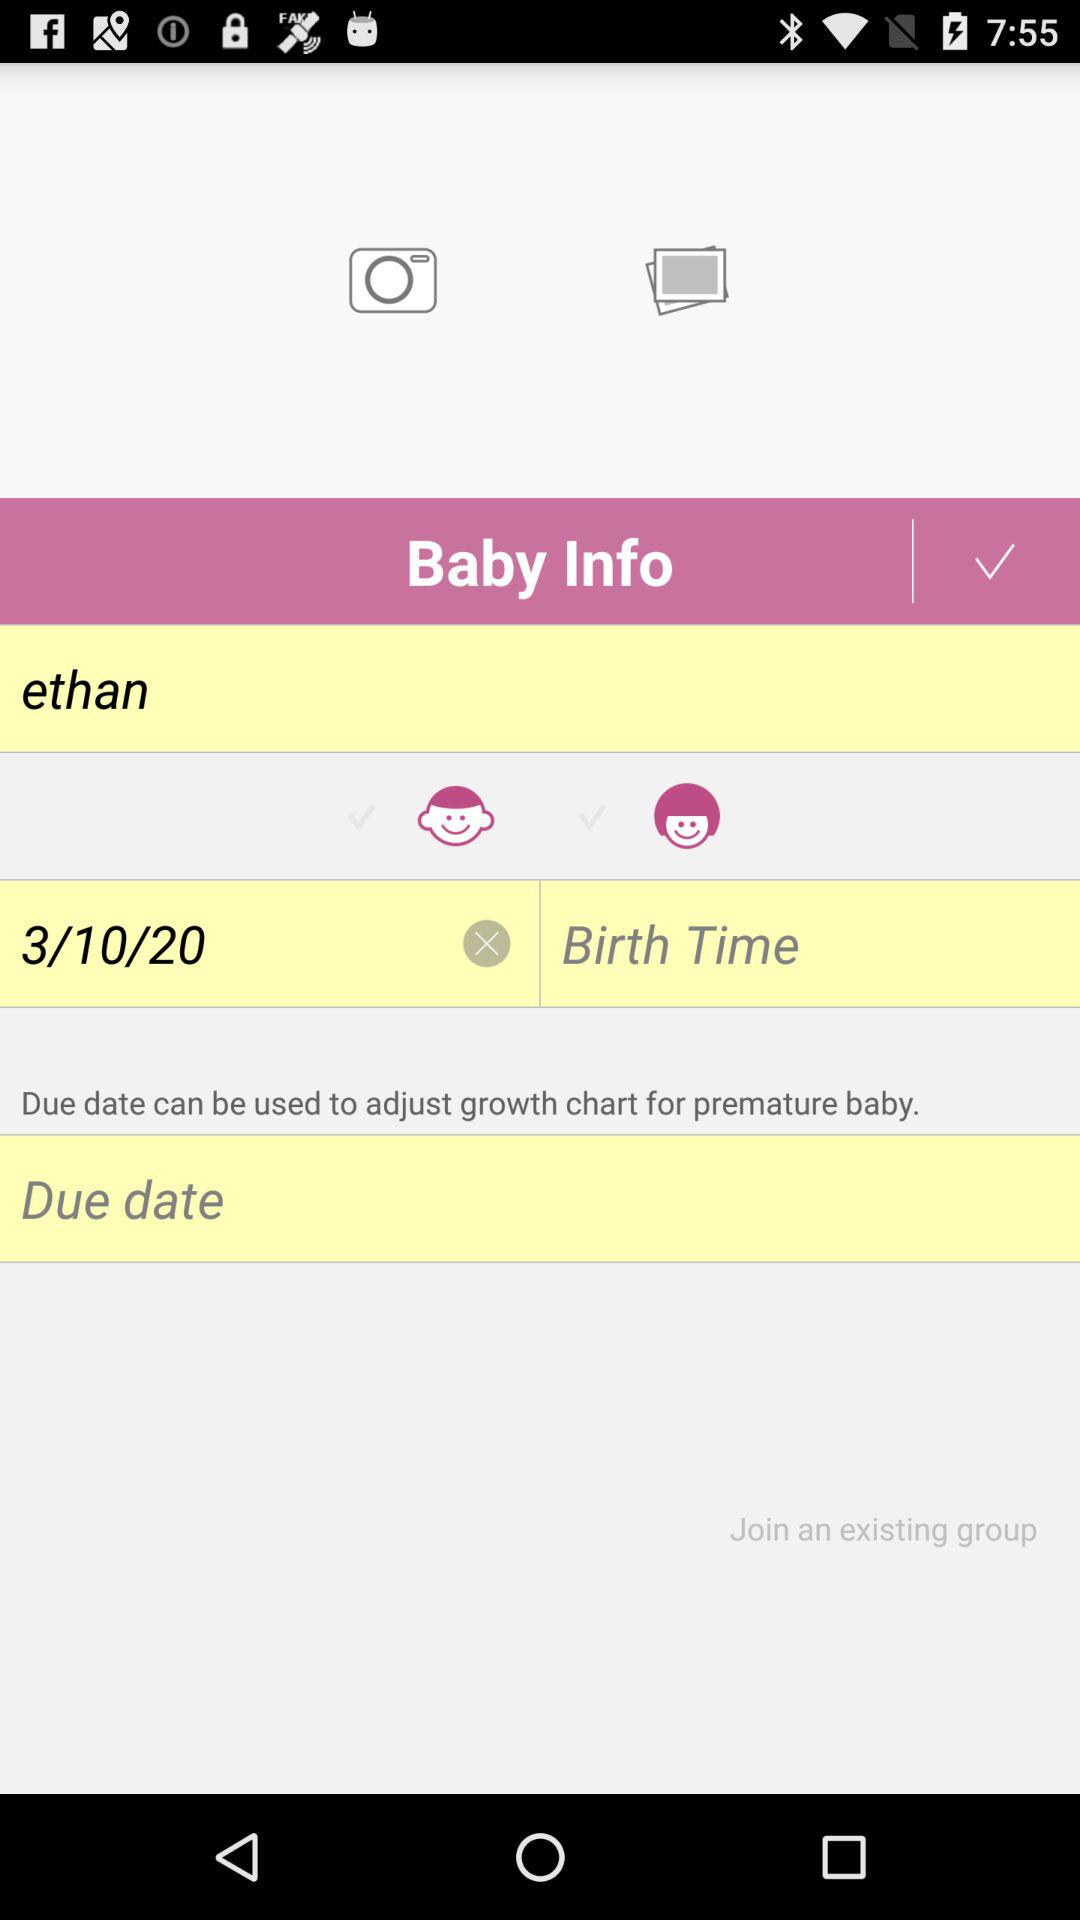On what date was the baby born? The baby was born on October 3, 2020. 